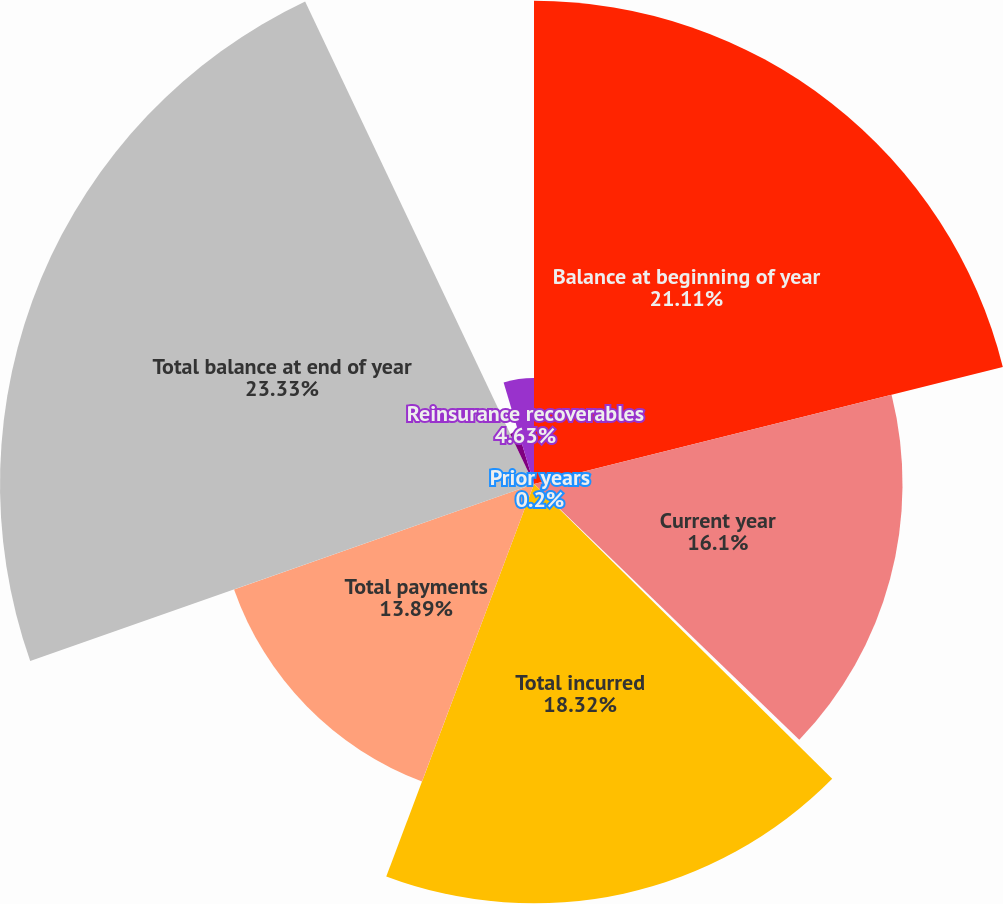Convert chart. <chart><loc_0><loc_0><loc_500><loc_500><pie_chart><fcel>Balance at beginning of year<fcel>Current year<fcel>Prior years<fcel>Total incurred<fcel>Total payments<fcel>Total balance at end of year<fcel>Claim adjustment expense<fcel>Reinsurance recoverables<nl><fcel>21.11%<fcel>16.1%<fcel>0.2%<fcel>18.32%<fcel>13.89%<fcel>23.33%<fcel>2.42%<fcel>4.63%<nl></chart> 